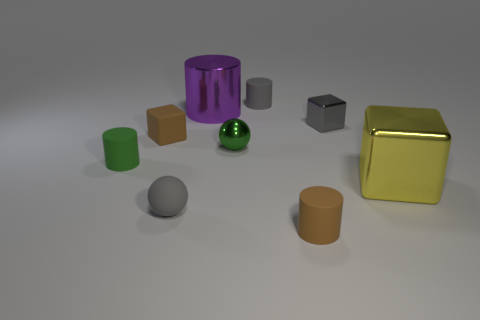There is a cylinder that is the same color as the rubber ball; what material is it?
Provide a succinct answer. Rubber. Is there anything else that is the same size as the rubber block?
Provide a short and direct response. Yes. There is a brown rubber object that is behind the brown matte thing in front of the tiny rubber block; what number of small green things are left of it?
Make the answer very short. 1. What is the block that is in front of the small gray metallic block and to the left of the big yellow object made of?
Give a very brief answer. Rubber. The metallic sphere is what color?
Offer a very short reply. Green. Is the number of small green metal things on the left side of the tiny green metallic ball greater than the number of tiny brown matte cubes that are behind the brown matte cube?
Your answer should be very brief. No. The small matte cylinder that is on the left side of the gray matte sphere is what color?
Your response must be concise. Green. There is a ball left of the large purple metal cylinder; is it the same size as the block that is on the right side of the small gray shiny cube?
Give a very brief answer. No. How many objects are green shiny objects or matte cylinders?
Give a very brief answer. 4. The block in front of the small brown matte thing left of the brown rubber cylinder is made of what material?
Offer a terse response. Metal. 